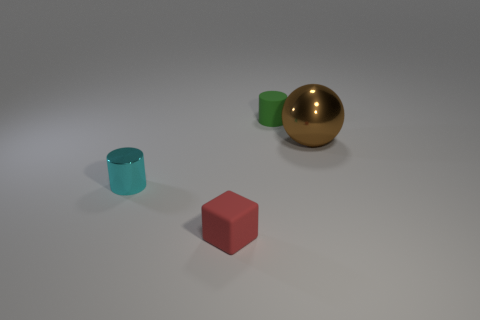Add 3 blue blocks. How many objects exist? 7 Subtract all blocks. How many objects are left? 3 Add 4 large shiny spheres. How many large shiny spheres are left? 5 Add 1 large metallic objects. How many large metallic objects exist? 2 Subtract 1 brown spheres. How many objects are left? 3 Subtract all balls. Subtract all big brown balls. How many objects are left? 2 